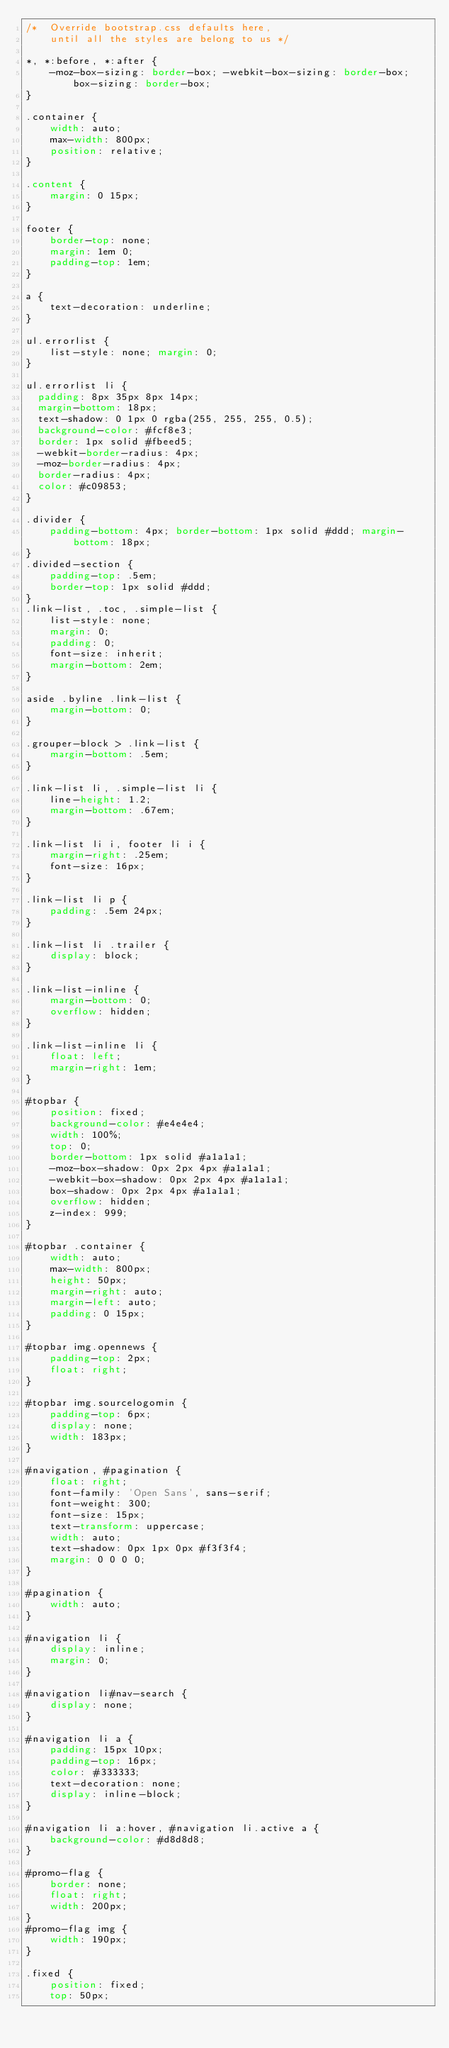Convert code to text. <code><loc_0><loc_0><loc_500><loc_500><_CSS_>/*  Override bootstrap.css defaults here, 
    until all the styles are belong to us */

*, *:before, *:after {
    -moz-box-sizing: border-box; -webkit-box-sizing: border-box; box-sizing: border-box;
}

.container {
    width: auto;
    max-width: 800px;
    position: relative;
}

.content {
    margin: 0 15px;
}

footer {
    border-top: none;
    margin: 1em 0;
    padding-top: 1em;
}

a {
    text-decoration: underline;
}

ul.errorlist {
    list-style: none; margin: 0;
}

ul.errorlist li {
  padding: 8px 35px 8px 14px;
  margin-bottom: 18px;
  text-shadow: 0 1px 0 rgba(255, 255, 255, 0.5);
  background-color: #fcf8e3;
  border: 1px solid #fbeed5;
  -webkit-border-radius: 4px;
  -moz-border-radius: 4px;
  border-radius: 4px;
  color: #c09853;
}

.divider {
    padding-bottom: 4px; border-bottom: 1px solid #ddd; margin-bottom: 18px;
}
.divided-section {
    padding-top: .5em;
    border-top: 1px solid #ddd;
}
.link-list, .toc, .simple-list {
    list-style: none;
    margin: 0;
    padding: 0;
    font-size: inherit;
    margin-bottom: 2em;
}

aside .byline .link-list {
    margin-bottom: 0;
}

.grouper-block > .link-list {
    margin-bottom: .5em;
}

.link-list li, .simple-list li {
    line-height: 1.2;
    margin-bottom: .67em;
}

.link-list li i, footer li i {
    margin-right: .25em;
    font-size: 16px;
}

.link-list li p {
    padding: .5em 24px;
}

.link-list li .trailer {
    display: block;
}

.link-list-inline {
    margin-bottom: 0;
    overflow: hidden;
}

.link-list-inline li {
    float: left;
    margin-right: 1em;
}

#topbar {
    position: fixed;
    background-color: #e4e4e4;
    width: 100%;
    top: 0;
    border-bottom: 1px solid #a1a1a1;
    -moz-box-shadow: 0px 2px 4px #a1a1a1;
    -webkit-box-shadow: 0px 2px 4px #a1a1a1;
    box-shadow: 0px 2px 4px #a1a1a1;
    overflow: hidden;
    z-index: 999;
}

#topbar .container {
    width: auto;
    max-width: 800px;
    height: 50px;
    margin-right: auto;
    margin-left: auto;
    padding: 0 15px;
}

#topbar img.opennews {
    padding-top: 2px;
    float: right;
}

#topbar img.sourcelogomin {
    padding-top: 6px;
    display: none;
    width: 183px;
}

#navigation, #pagination {
    float: right;
    font-family: 'Open Sans', sans-serif;
    font-weight: 300;
    font-size: 15px;
    text-transform: uppercase;
    width: auto;
    text-shadow: 0px 1px 0px #f3f3f4;
    margin: 0 0 0 0;
}

#pagination {
    width: auto;
}

#navigation li {
    display: inline;
    margin: 0;
}

#navigation li#nav-search {
    display: none;
}

#navigation li a {
    padding: 15px 10px;
    padding-top: 16px;
    color: #333333;
    text-decoration: none;
    display: inline-block;
}

#navigation li a:hover, #navigation li.active a {
    background-color: #d8d8d8;
}

#promo-flag {
    border: none;
    float: right;
    width: 200px;
}
#promo-flag img {
    width: 190px;
}

.fixed {
    position: fixed;
    top: 50px;</code> 